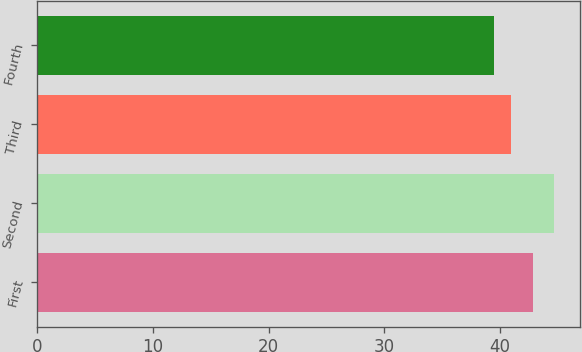Convert chart to OTSL. <chart><loc_0><loc_0><loc_500><loc_500><bar_chart><fcel>First<fcel>Second<fcel>Third<fcel>Fourth<nl><fcel>42.88<fcel>44.67<fcel>40.95<fcel>39.5<nl></chart> 